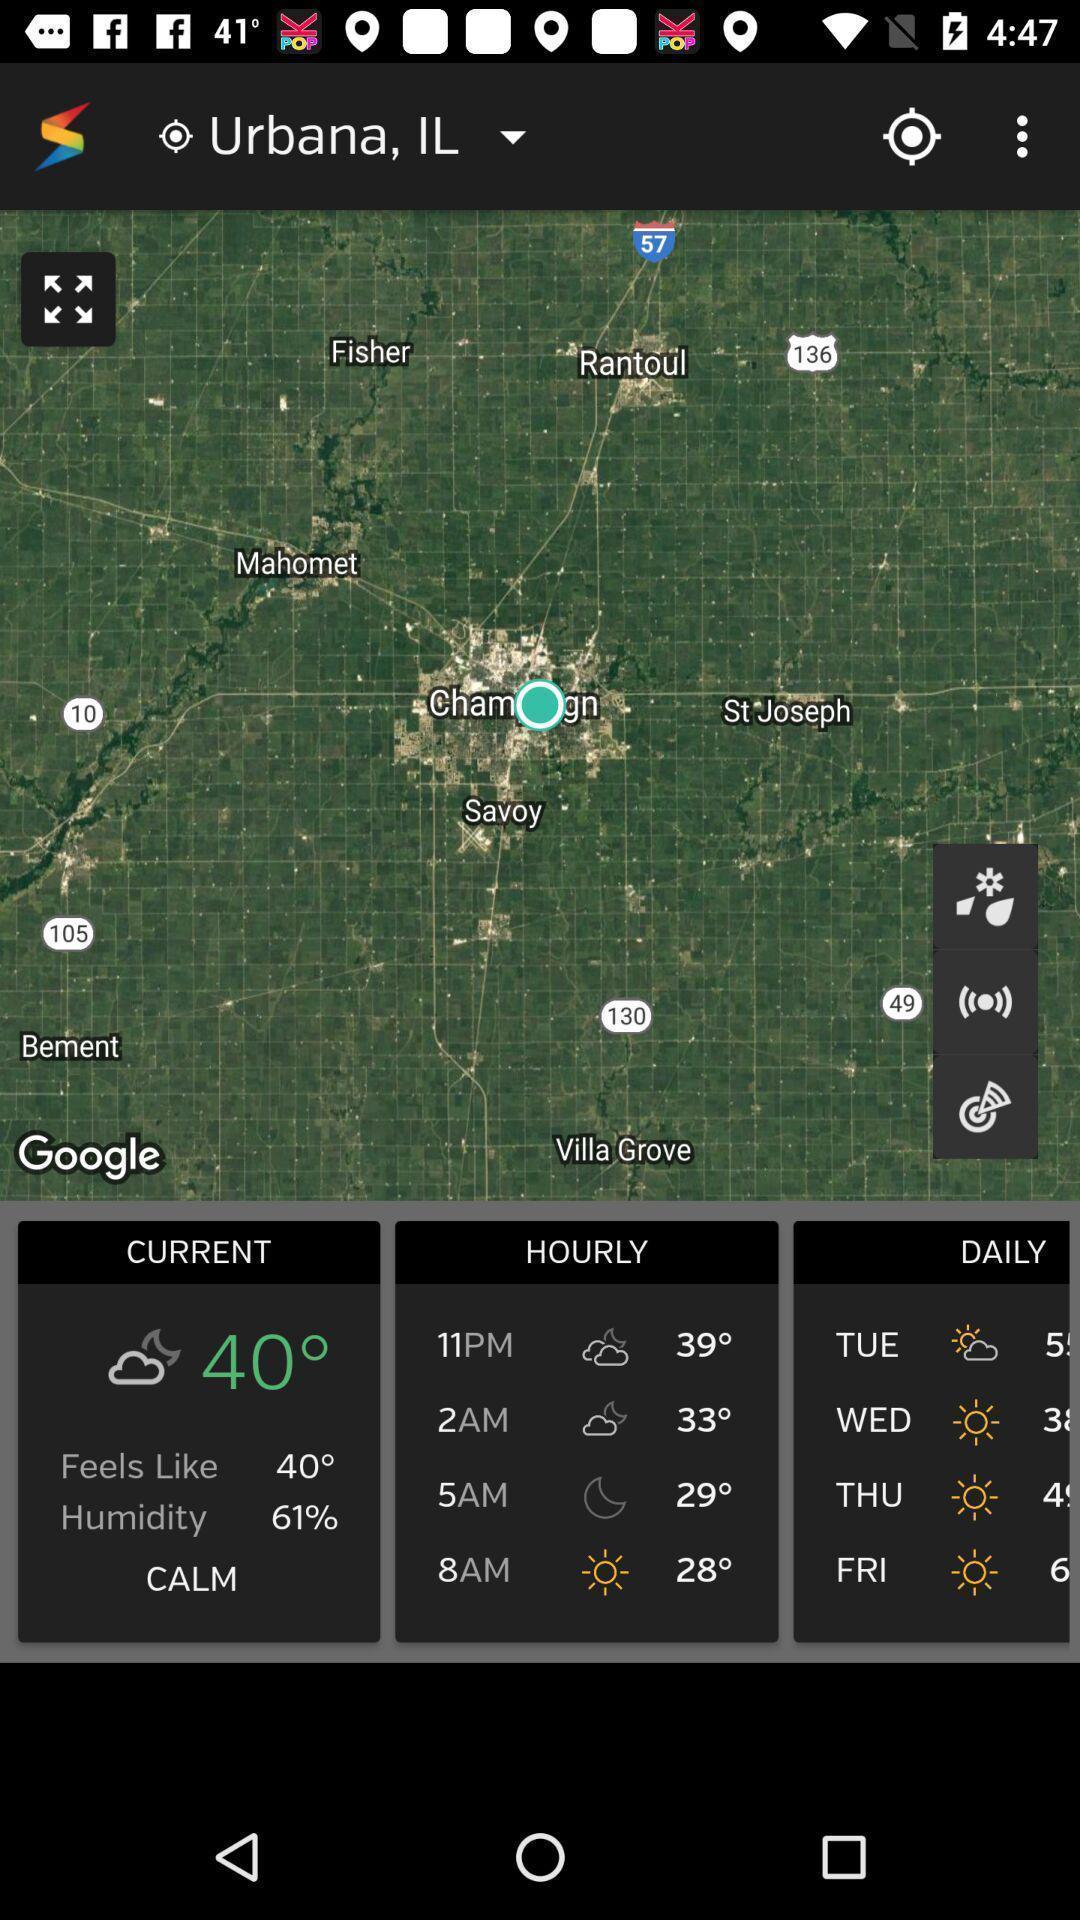Explain the elements present in this screenshot. Screen showing information about weather forecast. 